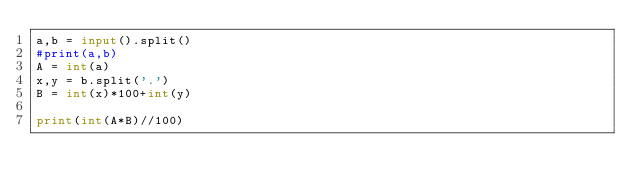<code> <loc_0><loc_0><loc_500><loc_500><_Python_>a,b = input().split()
#print(a,b)
A = int(a)
x,y = b.split('.')
B = int(x)*100+int(y)

print(int(A*B)//100)</code> 